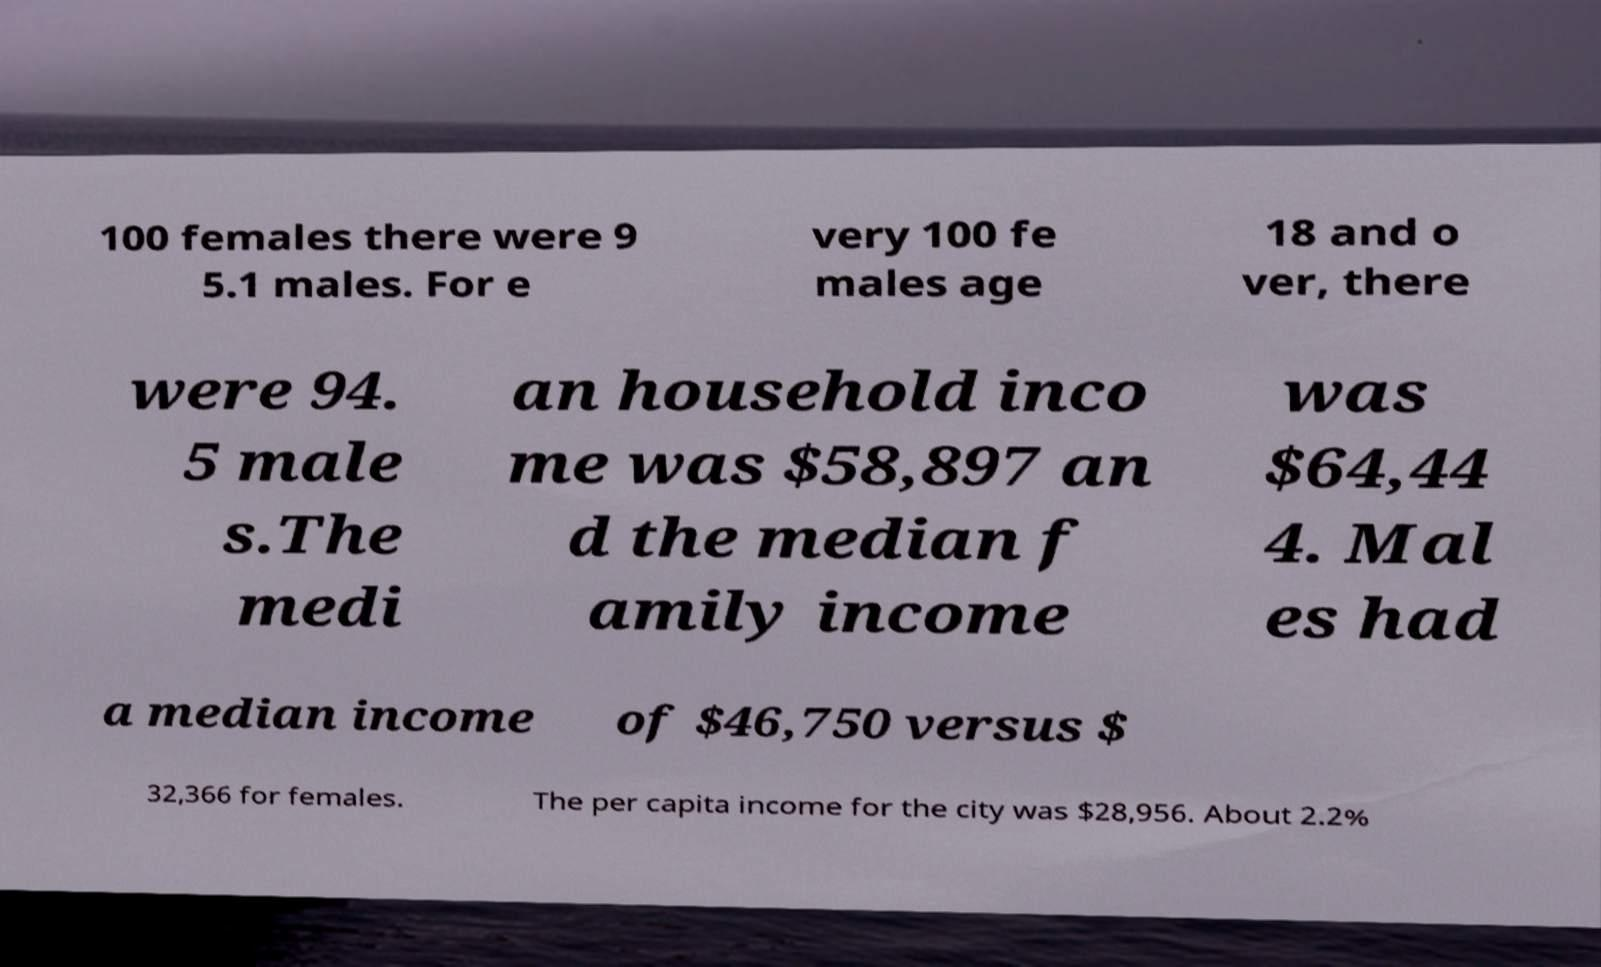Please identify and transcribe the text found in this image. 100 females there were 9 5.1 males. For e very 100 fe males age 18 and o ver, there were 94. 5 male s.The medi an household inco me was $58,897 an d the median f amily income was $64,44 4. Mal es had a median income of $46,750 versus $ 32,366 for females. The per capita income for the city was $28,956. About 2.2% 